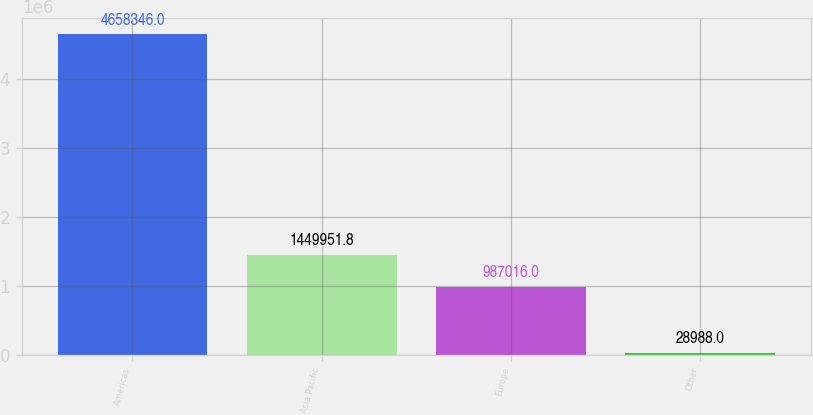Convert chart. <chart><loc_0><loc_0><loc_500><loc_500><bar_chart><fcel>Americas<fcel>Asia Pacific<fcel>Europe<fcel>Other<nl><fcel>4.65835e+06<fcel>1.44995e+06<fcel>987016<fcel>28988<nl></chart> 